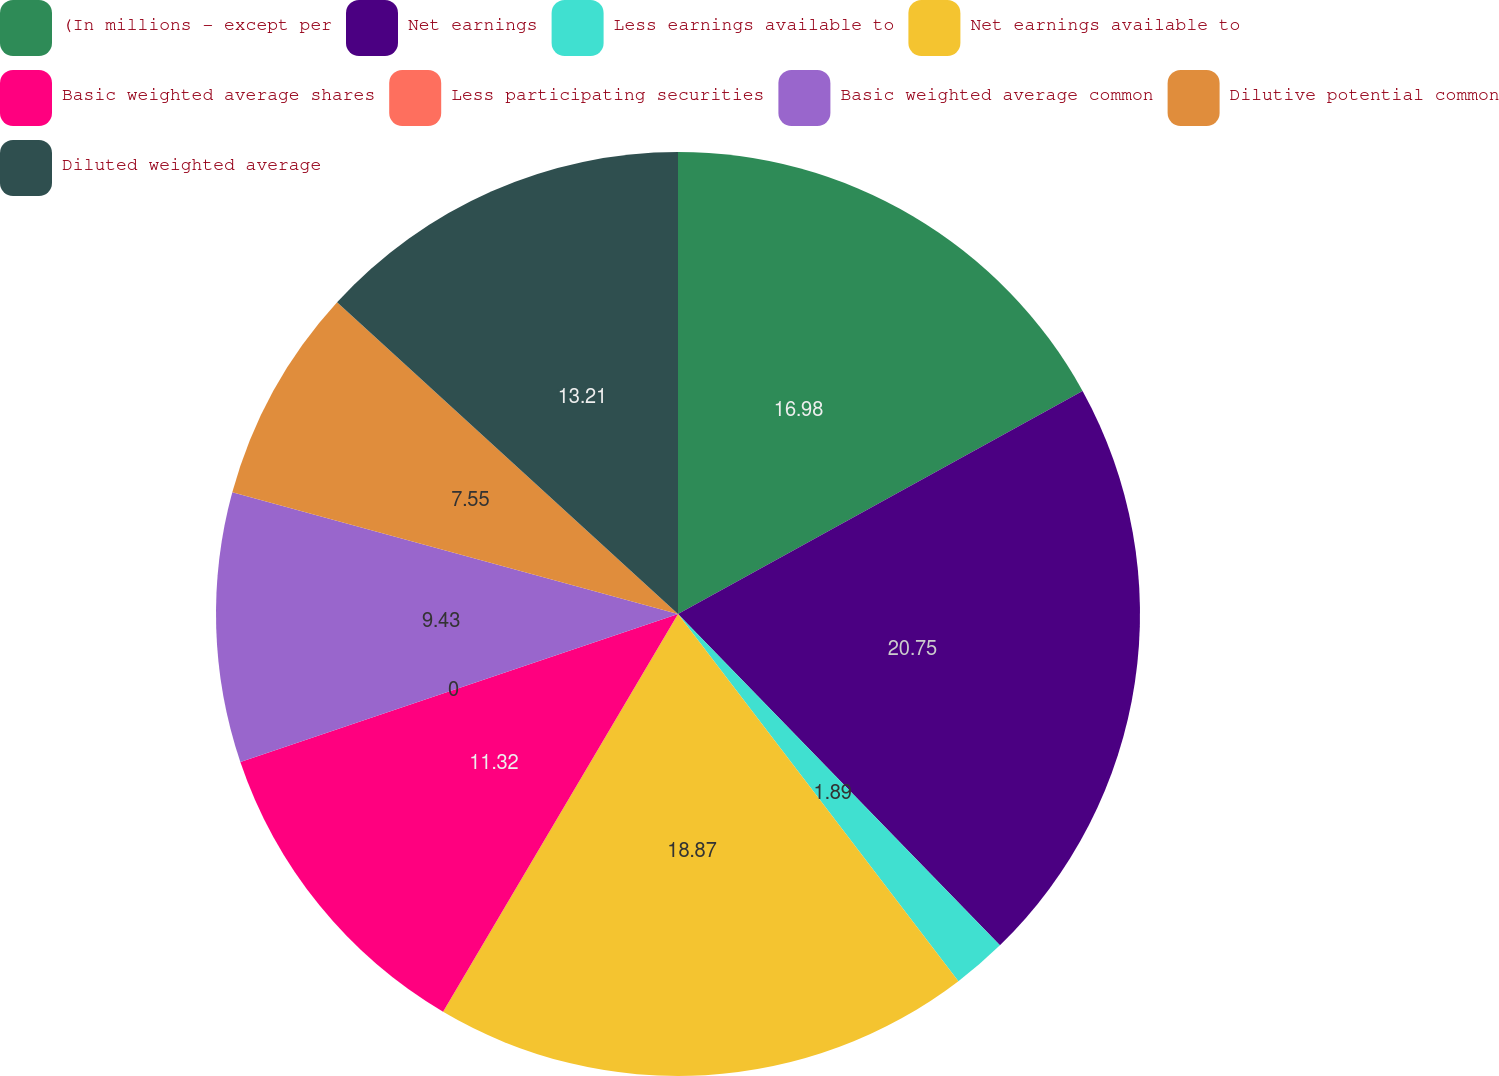Convert chart to OTSL. <chart><loc_0><loc_0><loc_500><loc_500><pie_chart><fcel>(In millions - except per<fcel>Net earnings<fcel>Less earnings available to<fcel>Net earnings available to<fcel>Basic weighted average shares<fcel>Less participating securities<fcel>Basic weighted average common<fcel>Dilutive potential common<fcel>Diluted weighted average<nl><fcel>16.98%<fcel>20.75%<fcel>1.89%<fcel>18.87%<fcel>11.32%<fcel>0.0%<fcel>9.43%<fcel>7.55%<fcel>13.21%<nl></chart> 